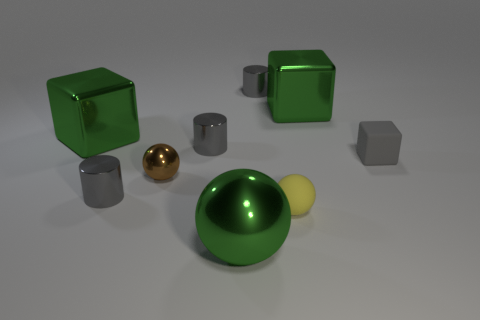The tiny matte object behind the yellow rubber object is what color?
Provide a succinct answer. Gray. What size is the yellow sphere that is the same material as the tiny gray cube?
Offer a terse response. Small. There is a green metallic thing that is the same shape as the brown shiny object; what is its size?
Provide a succinct answer. Large. Is there a rubber block?
Provide a short and direct response. Yes. How many things are shiny things behind the tiny brown ball or gray metal cylinders?
Offer a very short reply. 5. What material is the cube that is the same size as the yellow thing?
Offer a very short reply. Rubber. What color is the metallic cube right of the cylinder on the right side of the big green shiny sphere?
Keep it short and to the point. Green. How many spheres are behind the yellow thing?
Offer a terse response. 1. What is the color of the large sphere?
Your response must be concise. Green. What number of large objects are either metallic cylinders or purple rubber cubes?
Your answer should be very brief. 0. 